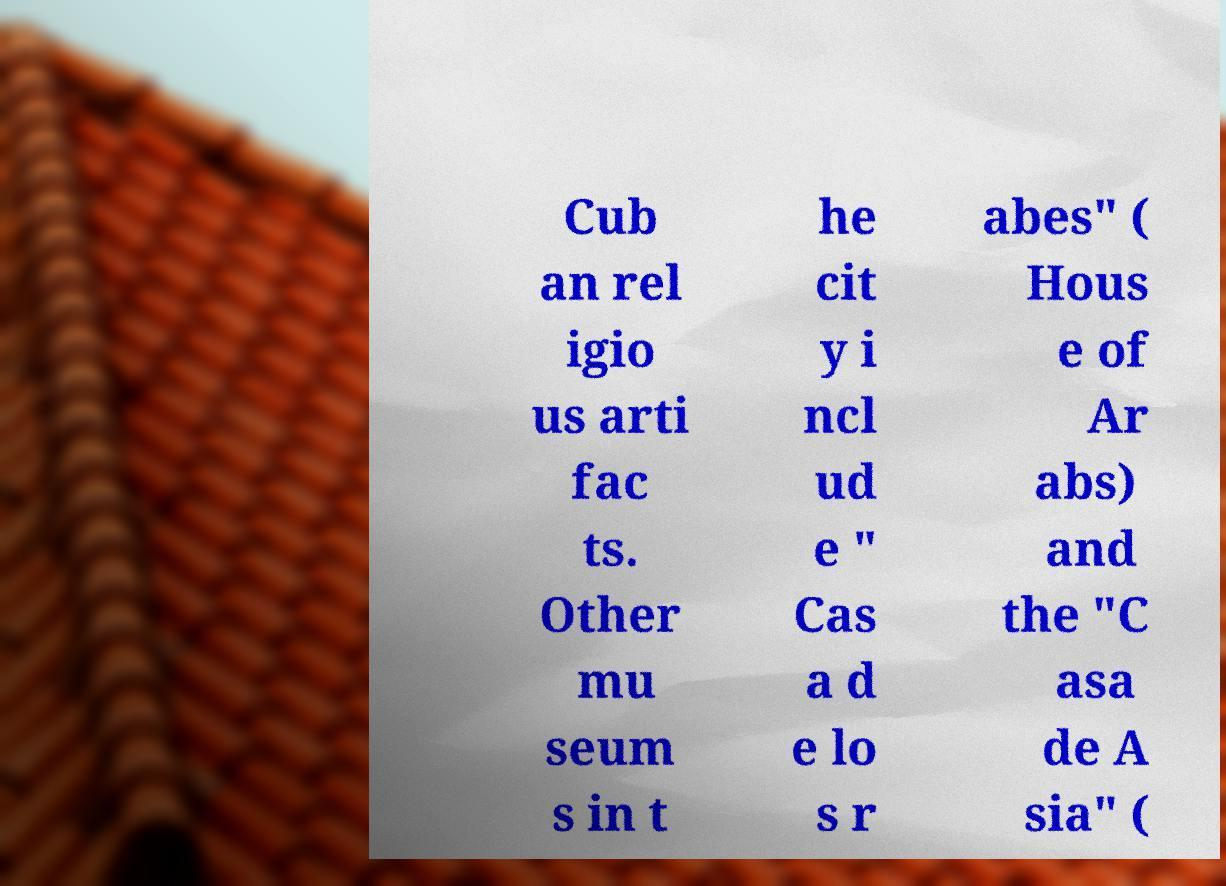Could you extract and type out the text from this image? Cub an rel igio us arti fac ts. Other mu seum s in t he cit y i ncl ud e " Cas a d e lo s r abes" ( Hous e of Ar abs) and the "C asa de A sia" ( 